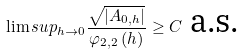Convert formula to latex. <formula><loc_0><loc_0><loc_500><loc_500>\lim s u p _ { h \rightarrow 0 } \frac { \sqrt { \left | A _ { 0 , h } \right | } } { \varphi _ { 2 , 2 } \left ( h \right ) } \geq C \text { a.s.}</formula> 